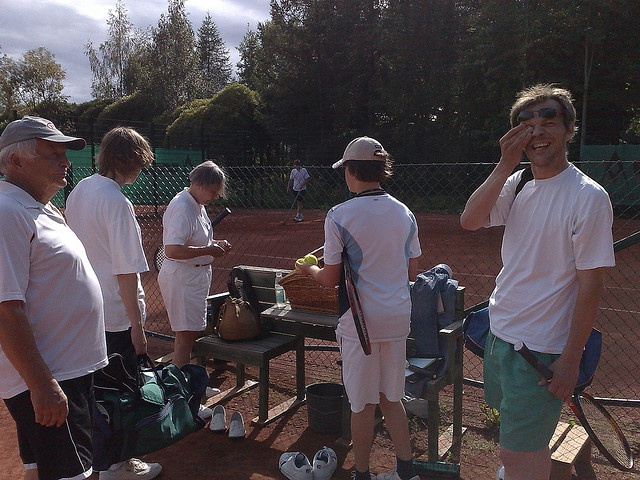Describe the objects in this image and their specific colors. I can see people in lavender, gray, maroon, and black tones, people in lavender, gray, black, and maroon tones, people in lavender, gray, black, and maroon tones, people in lavender, black, and gray tones, and people in lavender, gray, black, and maroon tones in this image. 